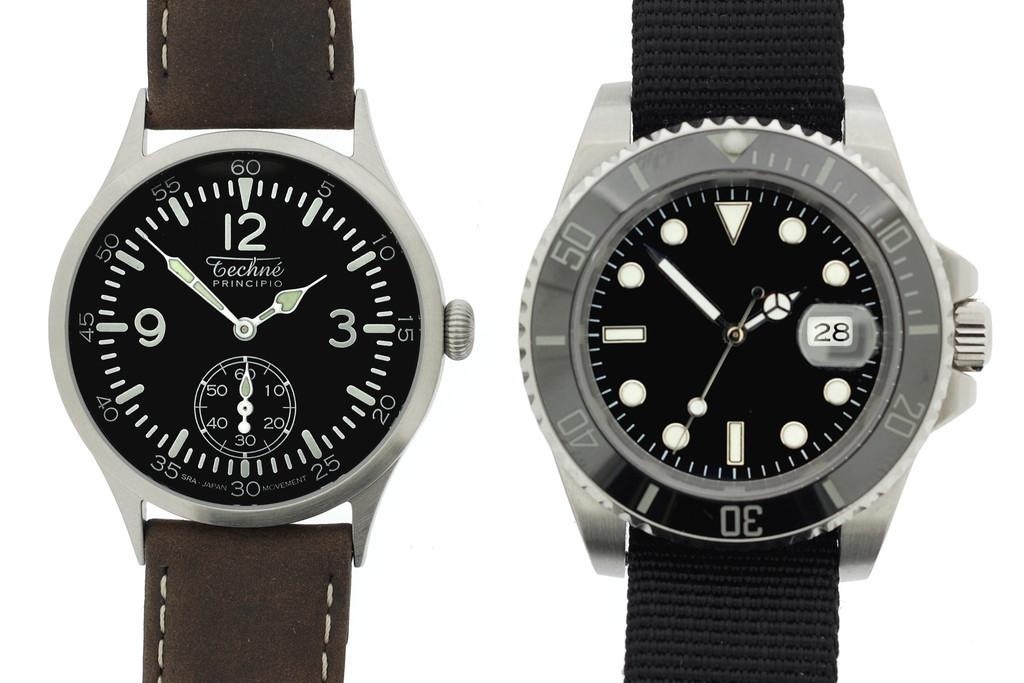Provide a one-sentence caption for the provided image. two watches, one says Techne PRINCIPIO. 